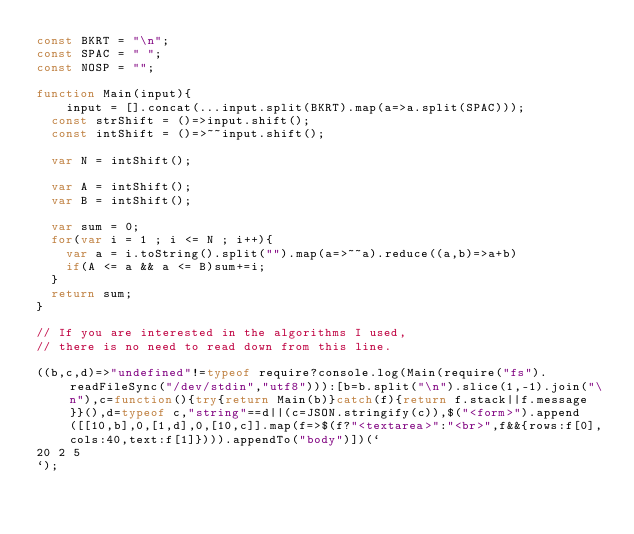<code> <loc_0><loc_0><loc_500><loc_500><_JavaScript_>const BKRT = "\n";
const SPAC = " ";
const NOSP = "";

function Main(input){
	input = [].concat(...input.split(BKRT).map(a=>a.split(SPAC)));
  const strShift = ()=>input.shift();
  const intShift = ()=>~~input.shift();
  
  var N = intShift();
  
  var A = intShift();
  var B = intShift();
  
  var sum = 0;
  for(var i = 1 ; i <= N ; i++){
  	var a = i.toString().split("").map(a=>~~a).reduce((a,b)=>a+b)
    if(A <= a && a <= B)sum+=i;
  }
  return sum;
}

// If you are interested in the algorithms I used, 
// there is no need to read down from this line.

((b,c,d)=>"undefined"!=typeof require?console.log(Main(require("fs").readFileSync("/dev/stdin","utf8"))):[b=b.split("\n").slice(1,-1).join("\n"),c=function(){try{return Main(b)}catch(f){return f.stack||f.message}}(),d=typeof c,"string"==d||(c=JSON.stringify(c)),$("<form>").append([[10,b],0,[1,d],0,[10,c]].map(f=>$(f?"<textarea>":"<br>",f&&{rows:f[0],cols:40,text:f[1]}))).appendTo("body")])(`
20 2 5
`);</code> 